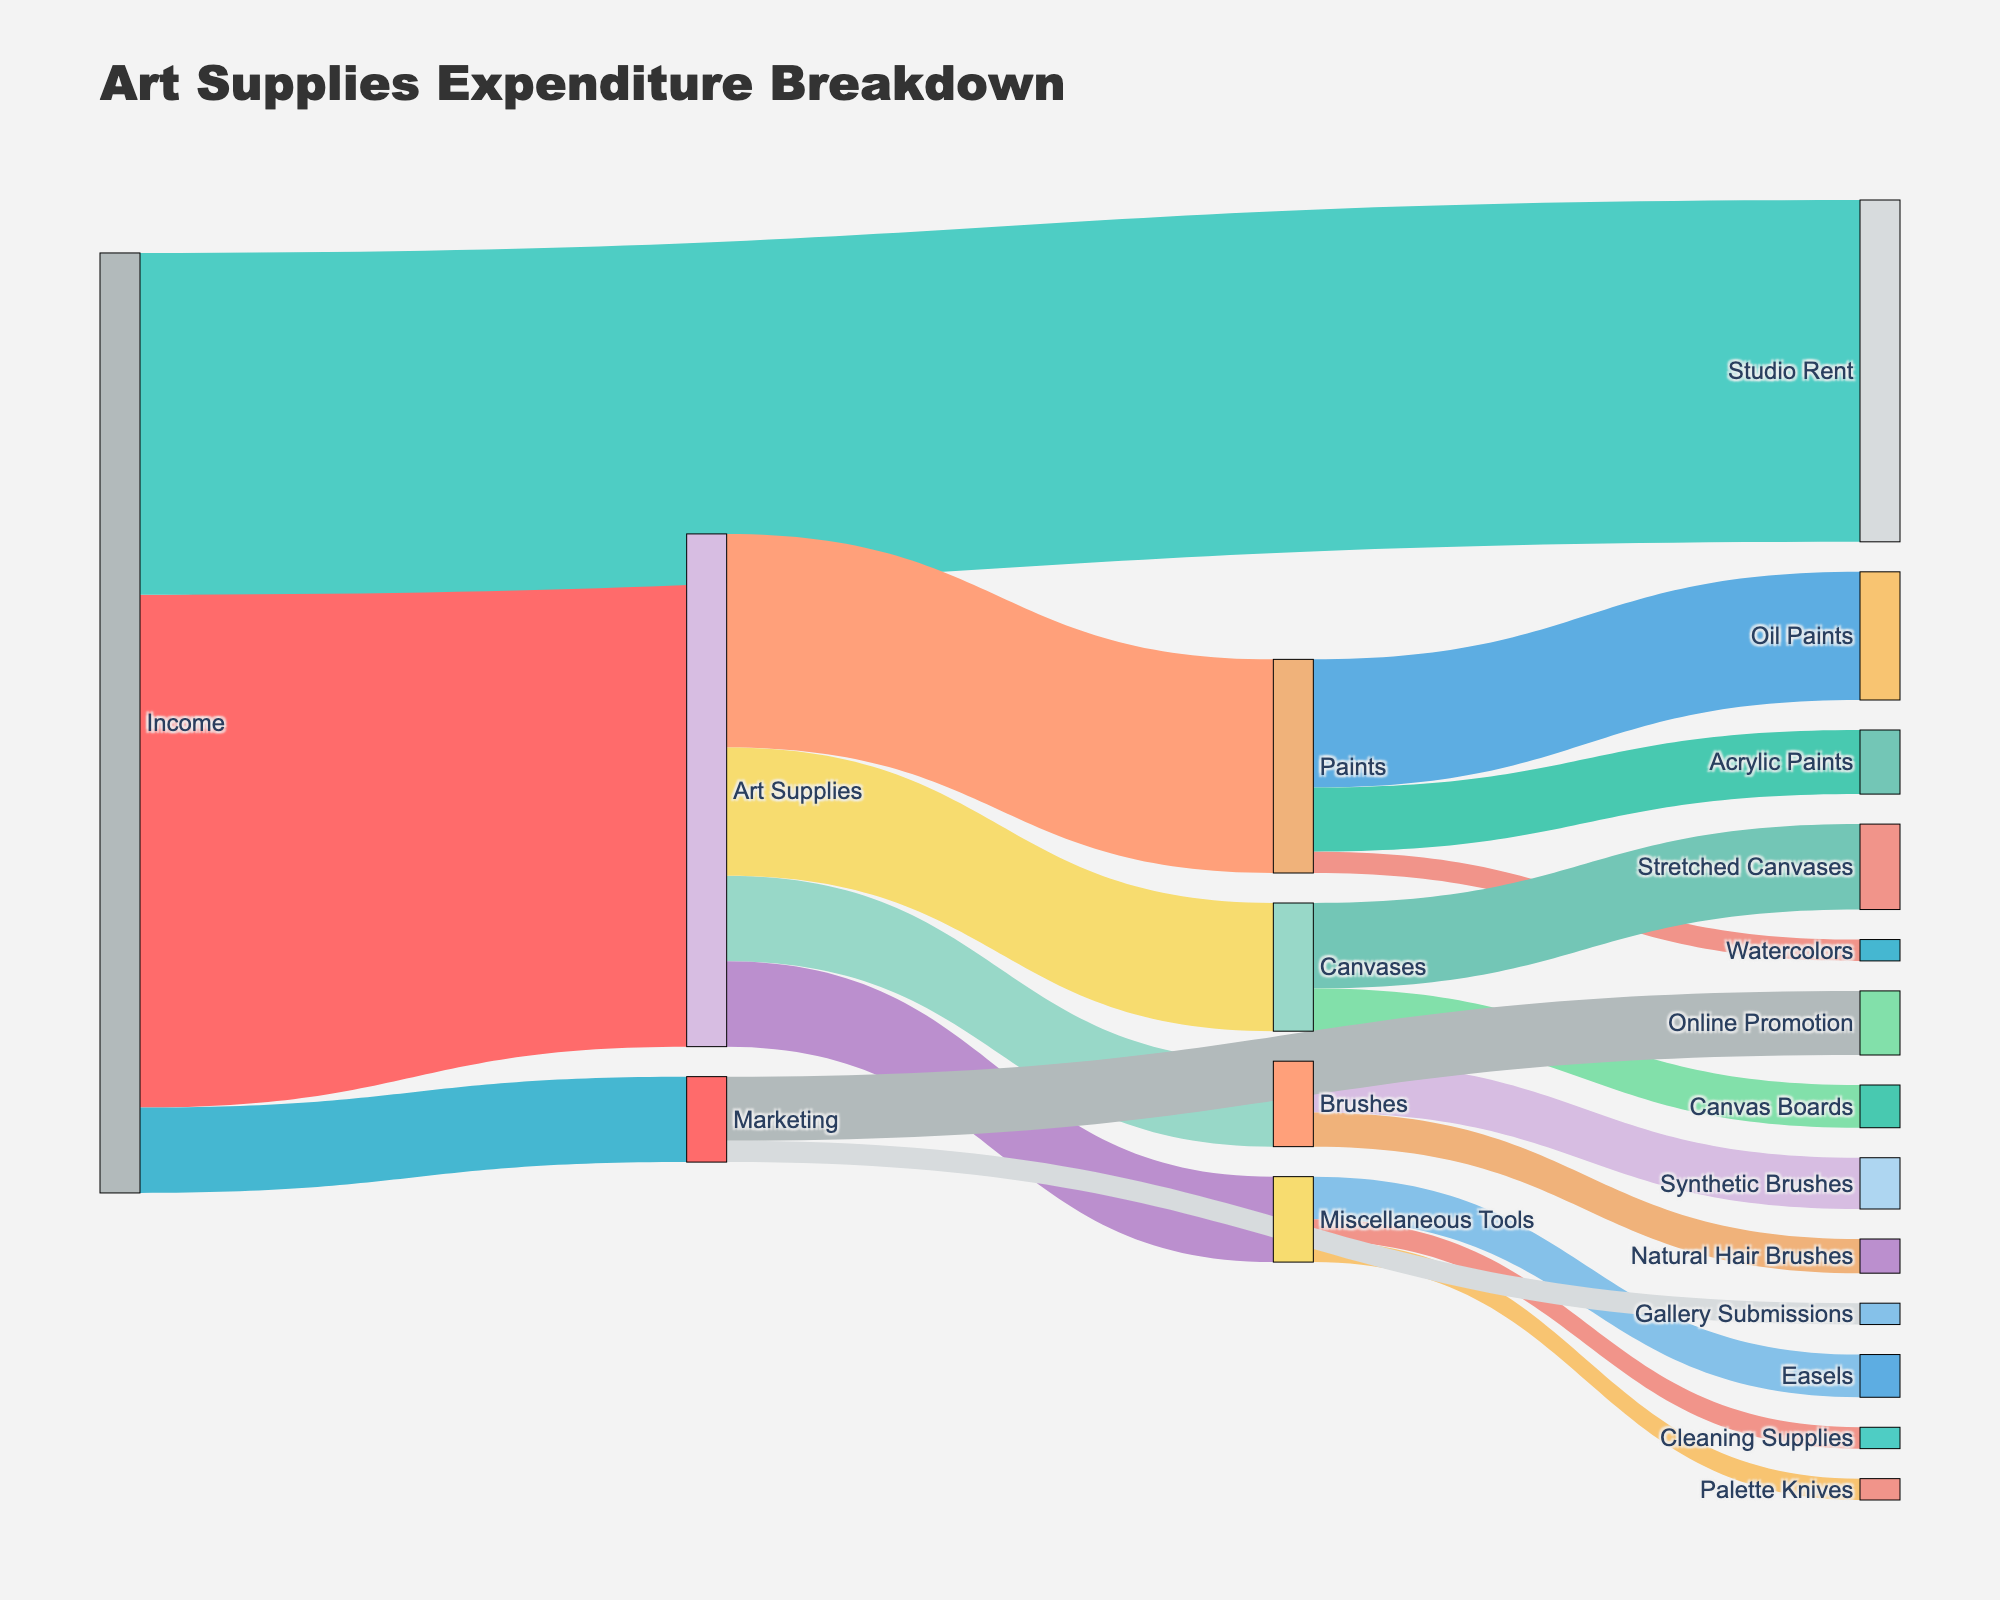What is the title of the Sankey Diagram? The title is prominently displayed at the top of the diagram. It reads "Art Supplies Expenditure Breakdown".
Answer: Art Supplies Expenditure Breakdown How much income is allocated to studio rent? The Sankey diagram shows the breakdown of income. The arrow labeled 'Studio Rent' coming from 'Income' shows the value, which is 800.
Answer: 800 Which category within Art Supplies has the highest expenditure? The arrows representing different categories within 'Art Supplies' have values indicating expenditure. 'Paints' has the highest value of 500.
Answer: Paints How much is spent on Oil Paints? By observing the split of 'Paints', the arrow labeled 'Oil Paints' shows an expenditure value of 300.
Answer: 300 What is the total amount spent on Marketing? The total expenditure on 'Marketing' can be seen directly from the diagram under 'Income', which is 200.
Answer: 200 How does the expenditure on Acrylic Paints compare to Oil Paints? From the breakdown of 'Paints', 'Acrylic Paints' has 150, and 'Oil Paints' has 300. Comparing these, the expenditure on Acrylic Paints is less.
Answer: Less What is the expenditure on canvases? The category 'Canvases' under 'Art Supplies' splits into 'Stretched Canvases' and 'Canvas Boards', summing up the expenditures (200 + 100) equals 300.
Answer: 300 Which type of brushes has a higher expenditure, Synthetic or Natural Hair? Under 'Brushes', 'Synthetic Brushes' shows an expenditure of 120, while 'Natural Hair Brushes' shows 80. Synthetic Brushes have a higher expenditure.
Answer: Synthetic Brushes What is the combined expenditure on Miscellaneous Tools? The sum of expenditures on 'Miscellaneous Tools' includes 'Palette Knives' (50), 'Easels' (100), and 'Cleaning Supplies' (50). Adding these values gives 50 + 100 + 50 = 200.
Answer: 200 How much more is spent on Online Promotion compared to Gallery Submissions? The expenditures are 150 for 'Online Promotion' and 50 for 'Gallery Submissions'. The difference is 150 - 50 = 100.
Answer: 100 